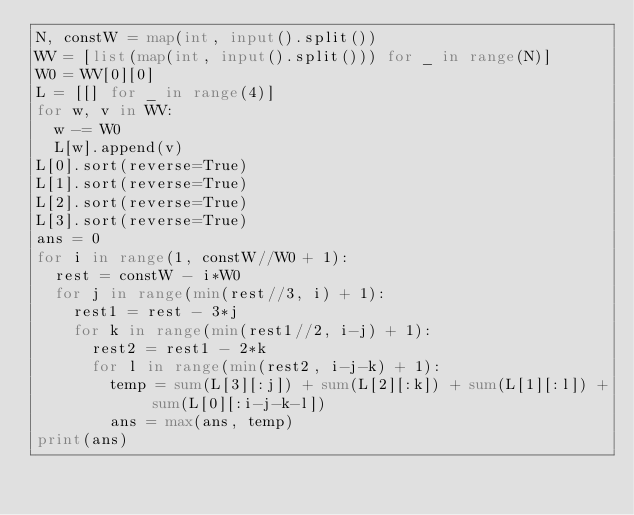<code> <loc_0><loc_0><loc_500><loc_500><_Python_>N, constW = map(int, input().split())
WV = [list(map(int, input().split())) for _ in range(N)]
W0 = WV[0][0]
L = [[] for _ in range(4)]
for w, v in WV:
  w -= W0
  L[w].append(v)
L[0].sort(reverse=True)
L[1].sort(reverse=True)
L[2].sort(reverse=True)
L[3].sort(reverse=True)
ans = 0
for i in range(1, constW//W0 + 1):
  rest = constW - i*W0
  for j in range(min(rest//3, i) + 1):
    rest1 = rest - 3*j
    for k in range(min(rest1//2, i-j) + 1):
      rest2 = rest1 - 2*k
      for l in range(min(rest2, i-j-k) + 1):
        temp = sum(L[3][:j]) + sum(L[2][:k]) + sum(L[1][:l]) + sum(L[0][:i-j-k-l])
        ans = max(ans, temp)
print(ans)</code> 